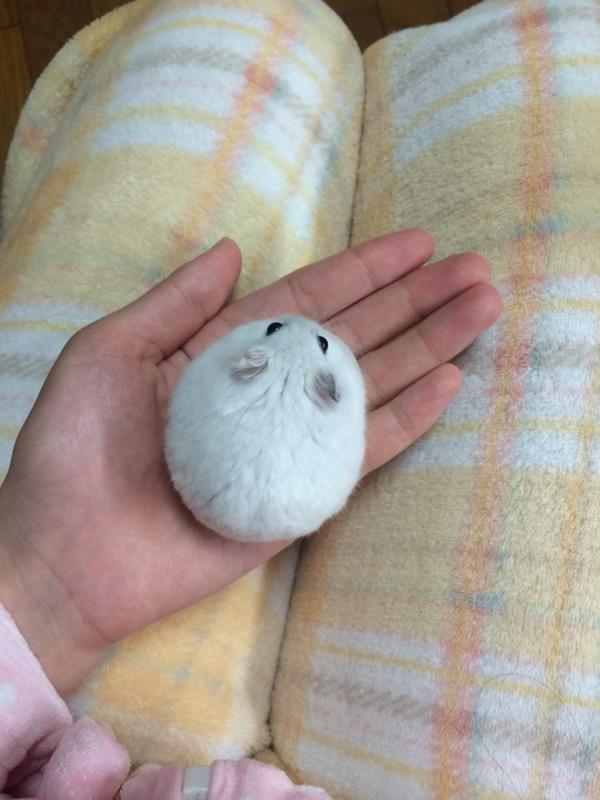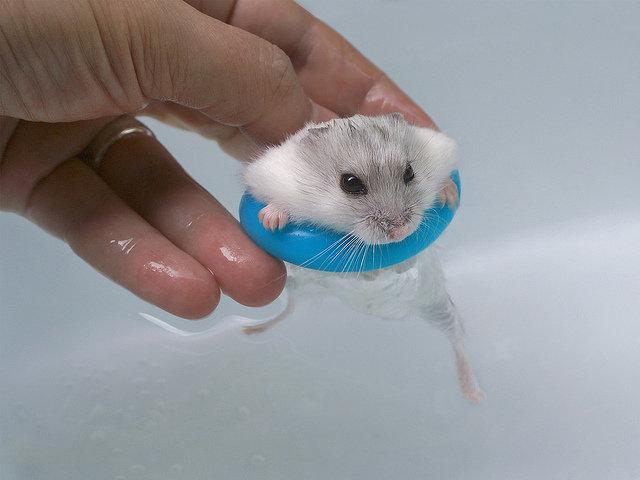The first image is the image on the left, the second image is the image on the right. Analyze the images presented: Is the assertion "A pet rodent is held in the palm of one hand in one image, and the other image shows a hamster looking mostly forward." valid? Answer yes or no. Yes. The first image is the image on the left, the second image is the image on the right. Examine the images to the left and right. Is the description "The right image contains a human hand holding a rodent." accurate? Answer yes or no. Yes. 